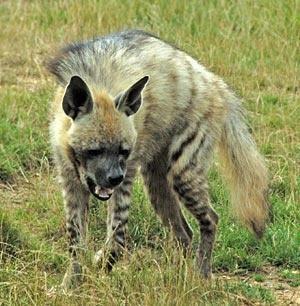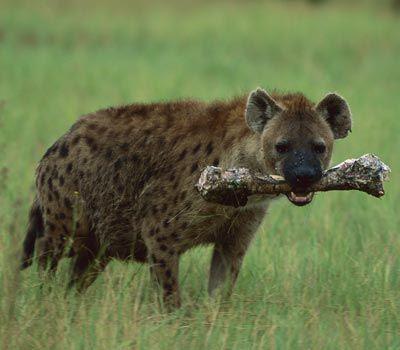The first image is the image on the left, the second image is the image on the right. Examine the images to the left and right. Is the description "Right image shows a hyena with nothing in its mouth." accurate? Answer yes or no. No. 